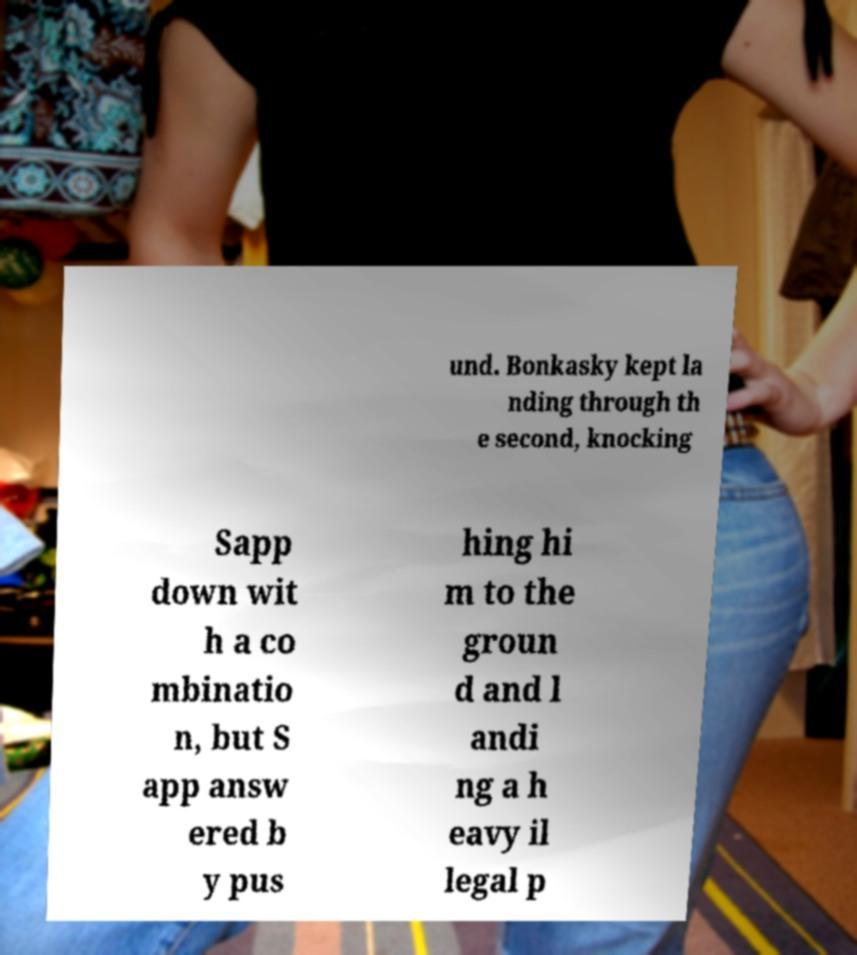Please read and relay the text visible in this image. What does it say? und. Bonkasky kept la nding through th e second, knocking Sapp down wit h a co mbinatio n, but S app answ ered b y pus hing hi m to the groun d and l andi ng a h eavy il legal p 